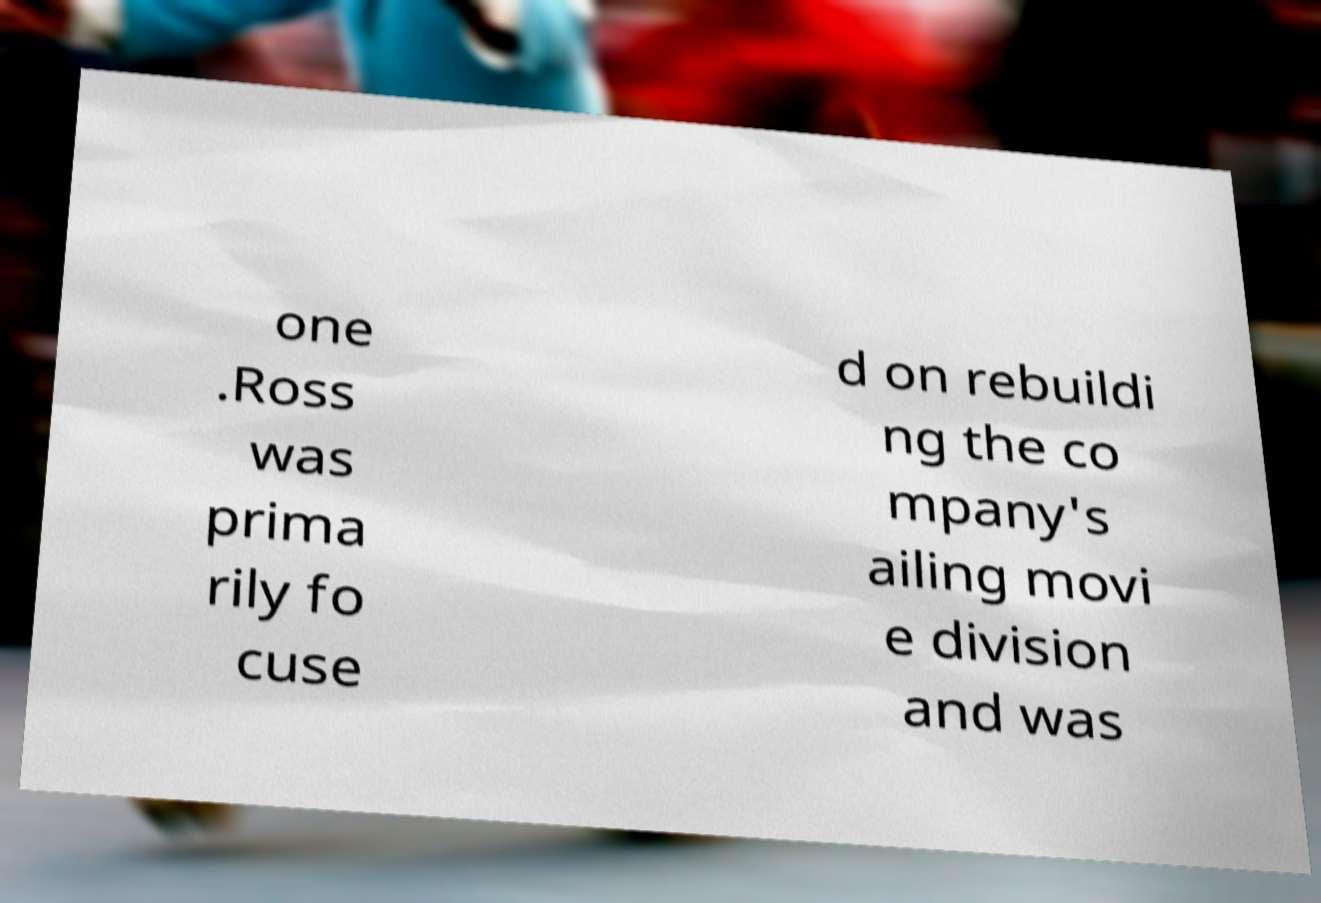Please read and relay the text visible in this image. What does it say? one .Ross was prima rily fo cuse d on rebuildi ng the co mpany's ailing movi e division and was 